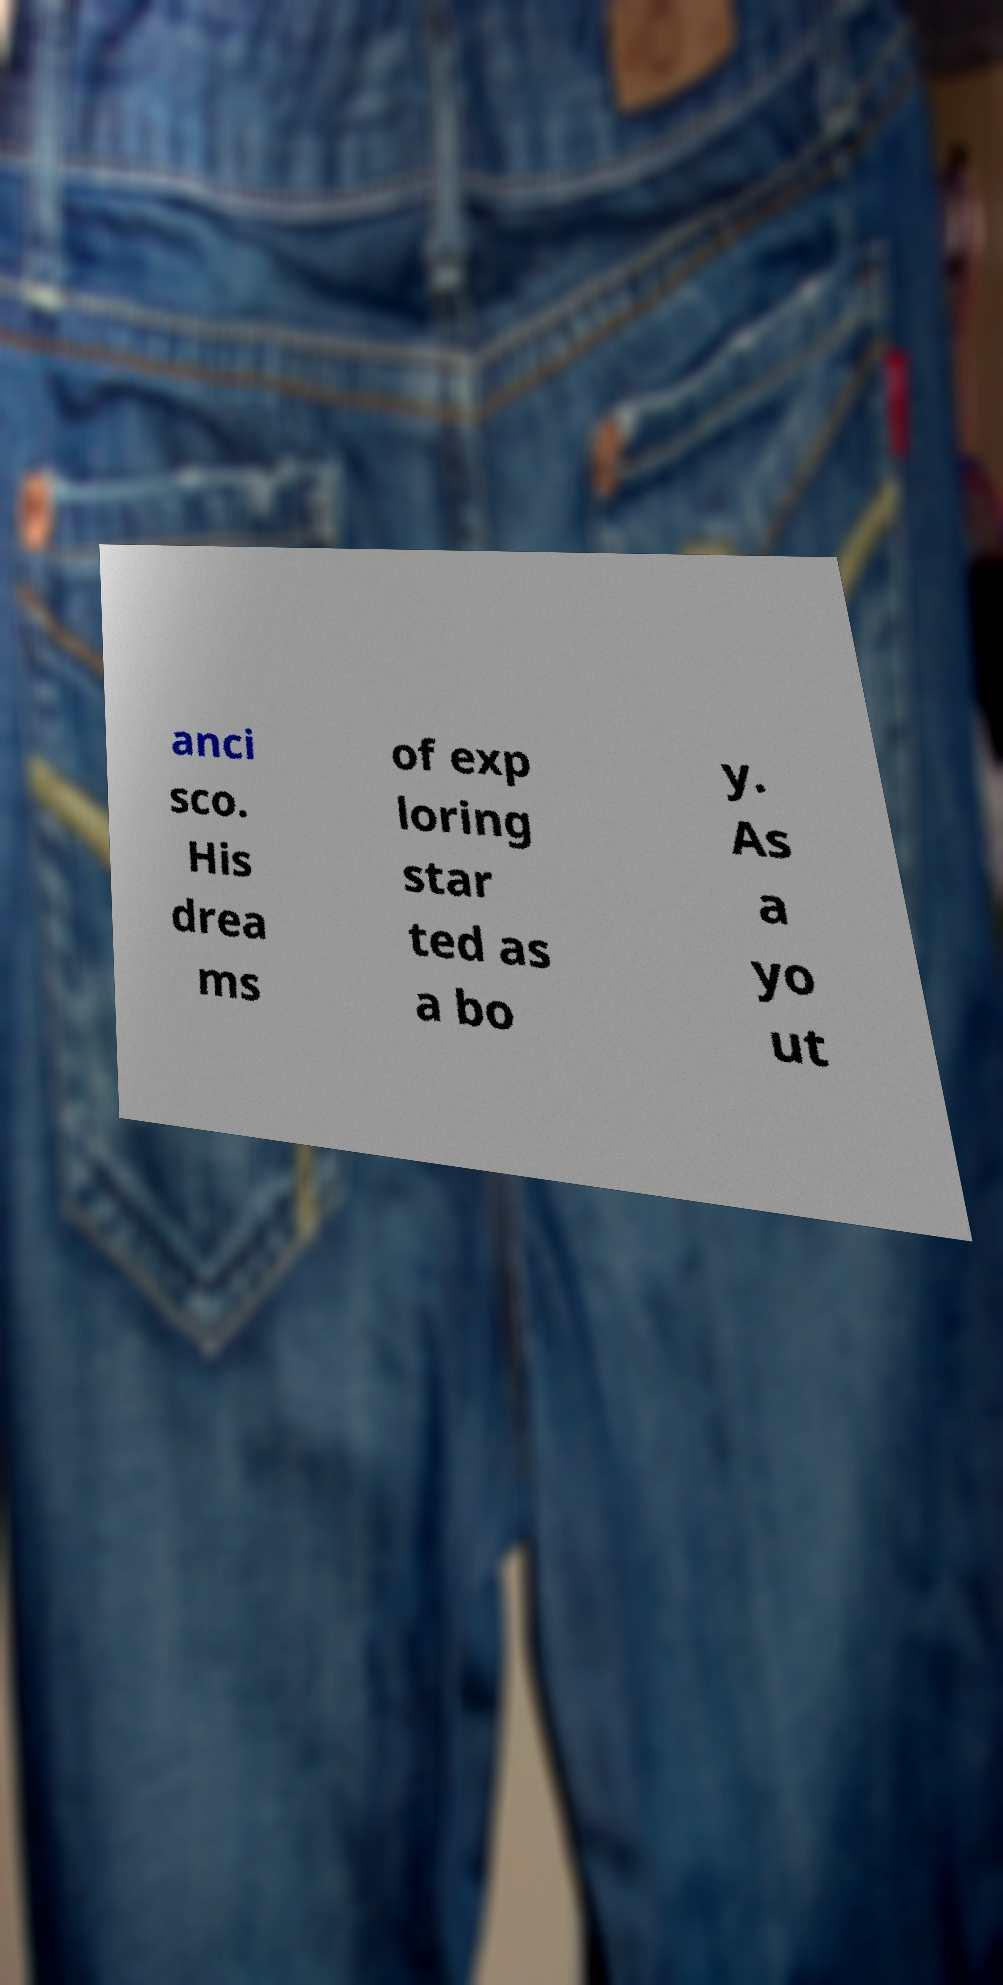Could you assist in decoding the text presented in this image and type it out clearly? anci sco. His drea ms of exp loring star ted as a bo y. As a yo ut 